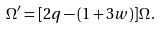<formula> <loc_0><loc_0><loc_500><loc_500>\Omega ^ { \prime } = [ 2 q - ( 1 + 3 w ) ] \Omega \, .</formula> 